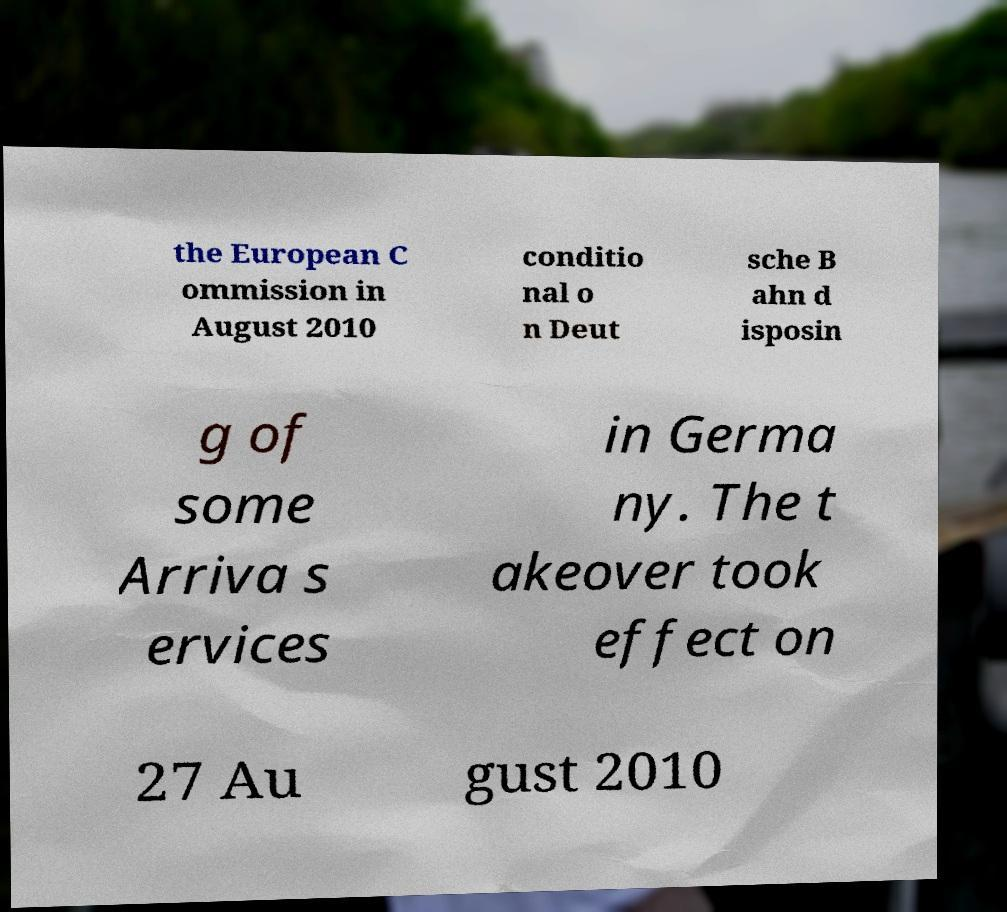There's text embedded in this image that I need extracted. Can you transcribe it verbatim? the European C ommission in August 2010 conditio nal o n Deut sche B ahn d isposin g of some Arriva s ervices in Germa ny. The t akeover took effect on 27 Au gust 2010 